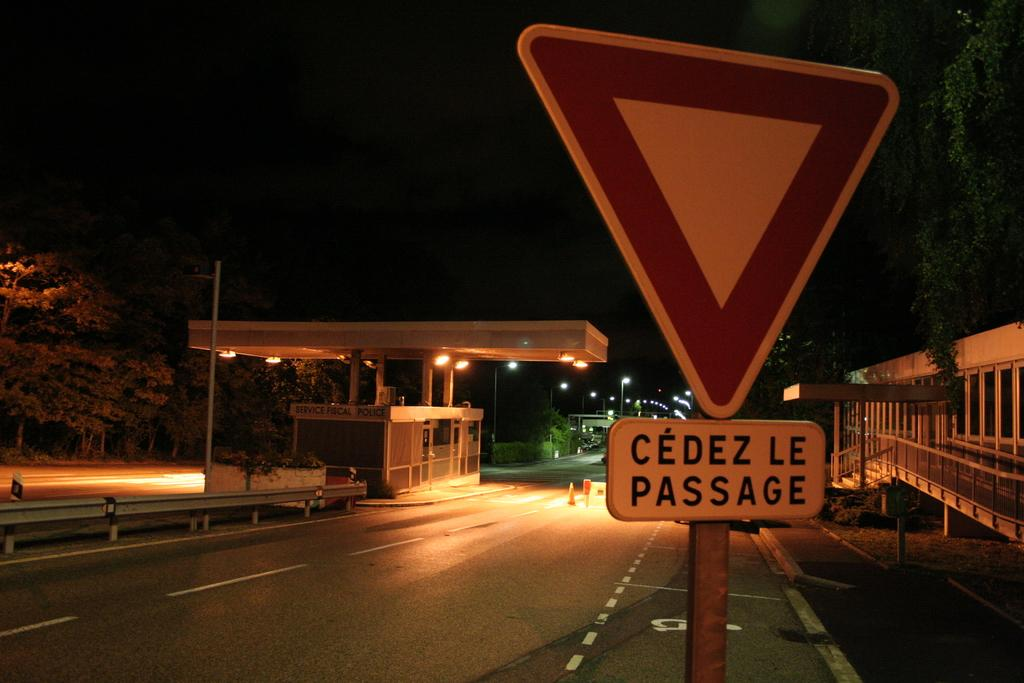What is the main object in the foreground of the image? There is a sign board in the image. What can be seen in the background of the image? There are roads, buildings, a railing, poles, lights, a pavement, and trees visible in the background of the image. Where is the hook located in the image? There is no hook present in the image. Can you see a stream in the image? There is no stream visible in the image. 